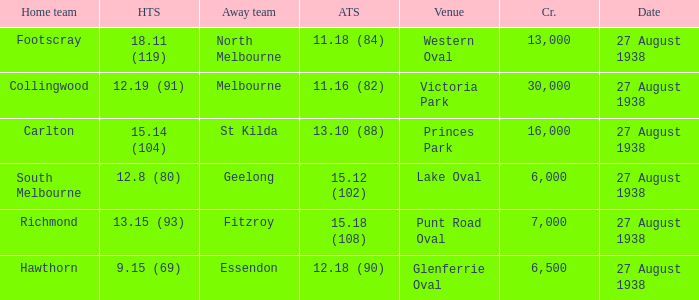What is the average crowd attendance for Collingwood? 30000.0. 